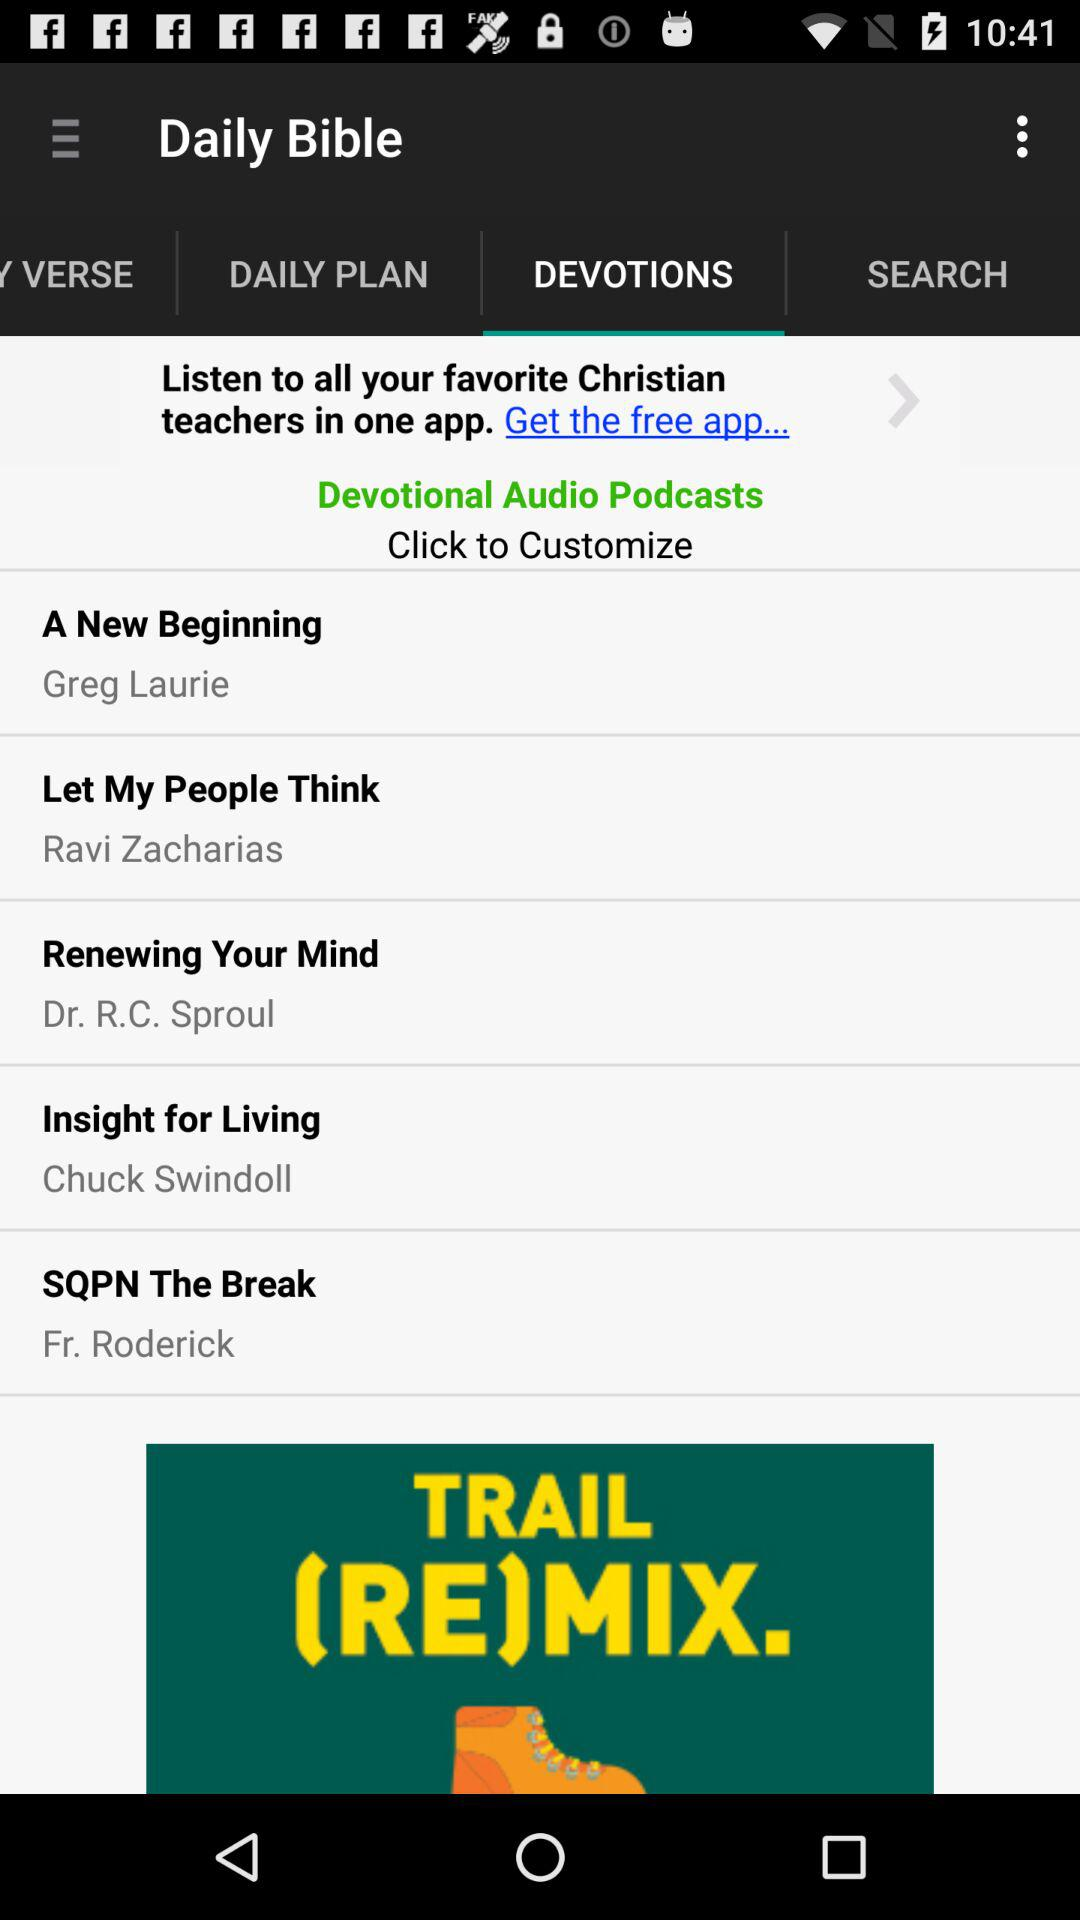Who is the author of "Let My People Think"? The author is Ravi Zacharias. 